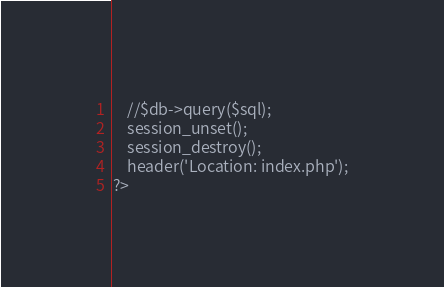<code> <loc_0><loc_0><loc_500><loc_500><_PHP_>    //$db->query($sql);
    session_unset();
    session_destroy(); 
    header('Location: index.php');
?>
</code> 